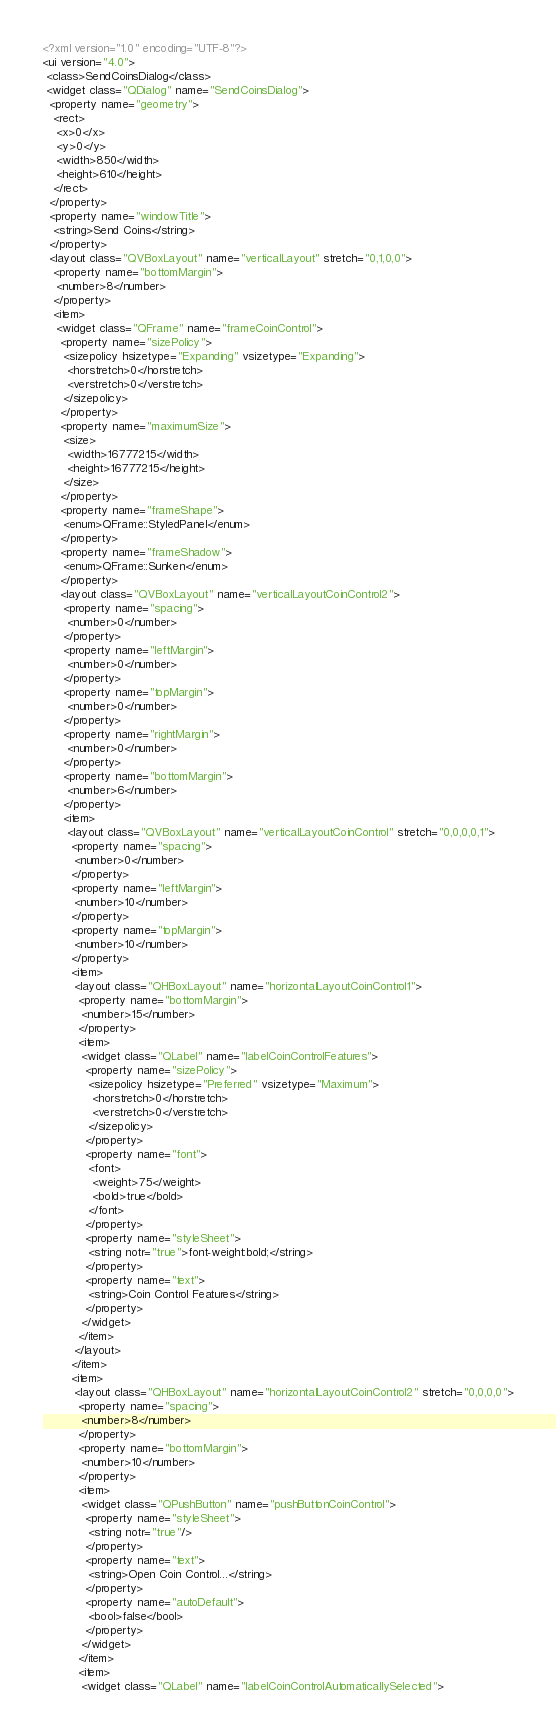<code> <loc_0><loc_0><loc_500><loc_500><_XML_><?xml version="1.0" encoding="UTF-8"?>
<ui version="4.0">
 <class>SendCoinsDialog</class>
 <widget class="QDialog" name="SendCoinsDialog">
  <property name="geometry">
   <rect>
    <x>0</x>
    <y>0</y>
    <width>850</width>
    <height>610</height>
   </rect>
  </property>
  <property name="windowTitle">
   <string>Send Coins</string>
  </property>
  <layout class="QVBoxLayout" name="verticalLayout" stretch="0,1,0,0">
   <property name="bottomMargin">
    <number>8</number>
   </property>
   <item>
    <widget class="QFrame" name="frameCoinControl">
     <property name="sizePolicy">
      <sizepolicy hsizetype="Expanding" vsizetype="Expanding">
       <horstretch>0</horstretch>
       <verstretch>0</verstretch>
      </sizepolicy>
     </property>
     <property name="maximumSize">
      <size>
       <width>16777215</width>
       <height>16777215</height>
      </size>
     </property>
     <property name="frameShape">
      <enum>QFrame::StyledPanel</enum>
     </property>
     <property name="frameShadow">
      <enum>QFrame::Sunken</enum>
     </property>
     <layout class="QVBoxLayout" name="verticalLayoutCoinControl2">
      <property name="spacing">
       <number>0</number>
      </property>
      <property name="leftMargin">
       <number>0</number>
      </property>
      <property name="topMargin">
       <number>0</number>
      </property>
      <property name="rightMargin">
       <number>0</number>
      </property>
      <property name="bottomMargin">
       <number>6</number>
      </property>
      <item>
       <layout class="QVBoxLayout" name="verticalLayoutCoinControl" stretch="0,0,0,0,1">
        <property name="spacing">
         <number>0</number>
        </property>
        <property name="leftMargin">
         <number>10</number>
        </property>
        <property name="topMargin">
         <number>10</number>
        </property>
        <item>
         <layout class="QHBoxLayout" name="horizontalLayoutCoinControl1">
          <property name="bottomMargin">
           <number>15</number>
          </property>
          <item>
           <widget class="QLabel" name="labelCoinControlFeatures">
            <property name="sizePolicy">
             <sizepolicy hsizetype="Preferred" vsizetype="Maximum">
              <horstretch>0</horstretch>
              <verstretch>0</verstretch>
             </sizepolicy>
            </property>
            <property name="font">
             <font>
              <weight>75</weight>
              <bold>true</bold>
             </font>
            </property>
            <property name="styleSheet">
             <string notr="true">font-weight:bold;</string>
            </property>
            <property name="text">
             <string>Coin Control Features</string>
            </property>
           </widget>
          </item>
         </layout>
        </item>
        <item>
         <layout class="QHBoxLayout" name="horizontalLayoutCoinControl2" stretch="0,0,0,0">
          <property name="spacing">
           <number>8</number>
          </property>
          <property name="bottomMargin">
           <number>10</number>
          </property>
          <item>
           <widget class="QPushButton" name="pushButtonCoinControl">
            <property name="styleSheet">
             <string notr="true"/>
            </property>
            <property name="text">
             <string>Open Coin Control...</string>
            </property>
            <property name="autoDefault">
             <bool>false</bool>
            </property>
           </widget>
          </item>
          <item>
           <widget class="QLabel" name="labelCoinControlAutomaticallySelected"></code> 